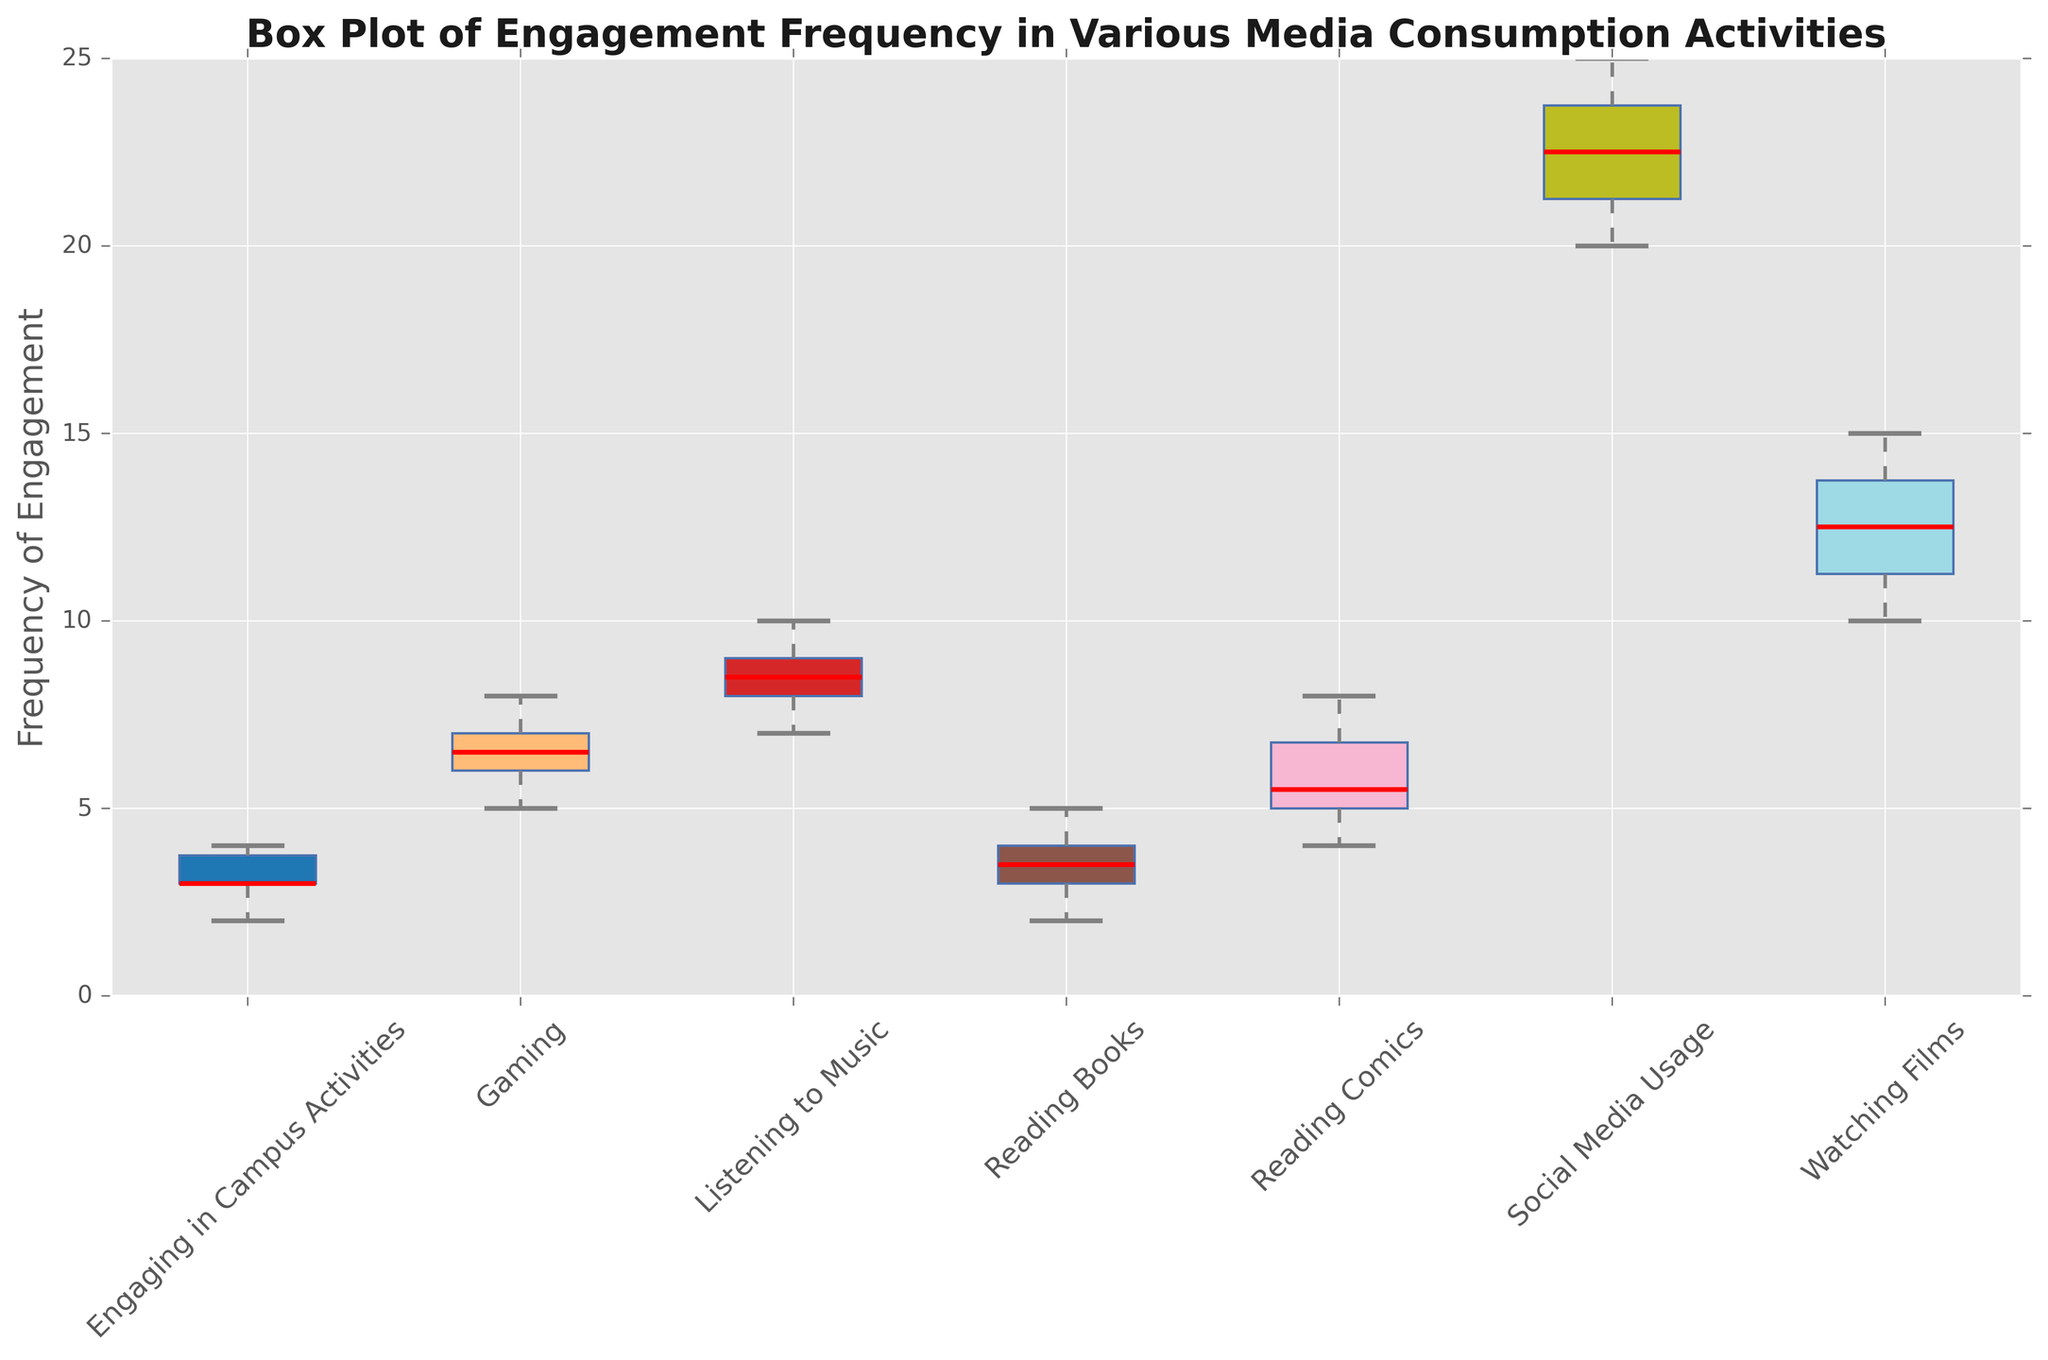What's the median frequency of engagement in Reading Comics? To find the median, the data for Reading Comics needs to be sorted in ascending order: [4, 5, 5, 6, 7, 8]. The median is the middle value, and if there are an even number of data points, it will be the average of the two central numbers. Here, the median will be (5 + 6) / 2 = 5.5.
Answer: 5.5 Which activity has the highest median frequency of engagement? The medians for each activity are: Reading Comics (5.5), Watching Films (12.5), Social Media Usage (22.5), Reading Books (3.5), Listening to Music (8.5), Gaming (6.5), Engaging in Campus Activities (3.0). The highest median is for Social Media Usage.
Answer: Social Media Usage Which activity has the lowest interquartile range (IQR)? The IQR is calculated as the difference between the third (Q3) and first quartile (Q1). Reading Comics (Q3-Q1 = 7-5 = 2), Watching Films (Q3-Q1 = 14-11 = 3), Social Media Usage (Q3-Q1 = 24-21 = 3), Reading Books (Q3-Q1 = 4-3 = 1), Listening to Music (Q3-Q1 = 9-8 = 1), Gaming (Q3-Q1 = 7-6 = 1), Engaging in Campus Activities (Q3-Q1 = 4-3 = 1). The lowest IQR is for Reading Books, Listening to Music, Gaming, and Engaging in Campus Activities, all having IQR of 1.
Answer: Reading Books, Listening to Music, Gaming, Engaging in Campus Activities Is the box plot for Watching Films skewed to the left, right, or symmetric? To determine skewness from a box plot, we compare the lengths of the whiskers and the positions of the median. For Watching Films, the median is closer to the lower quartile (Q1), and the upper whisker is longer than the lower whisker, indicating it is positively skewed (right-skewed).
Answer: Right-skewed Among all activities, which one has the smallest range in the frequency of engagement? The range is calculated as the difference between the maximum and minimum values. Reading Comics (8-4 = 4), Watching Films (15-10 = 5), Social Media Usage (25-20 = 5), Reading Books (5-2 = 3), Listening to Music (10-7 = 3), Gaming (8-5 = 3), Engaging in Campus Activities (4-2 = 2). The smallest range is for Engaging in Campus Activities.
Answer: Engaging in Campus Activities 